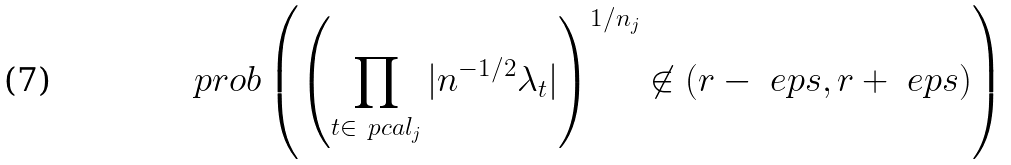<formula> <loc_0><loc_0><loc_500><loc_500>\ p r o b \left ( \left ( \prod _ { t \in \ p c a l _ { j } } | n ^ { - 1 / 2 } \lambda _ { t } | \right ) ^ { 1 / n _ { j } } \not \in ( r - \ e p s , r + \ e p s ) \right )</formula> 